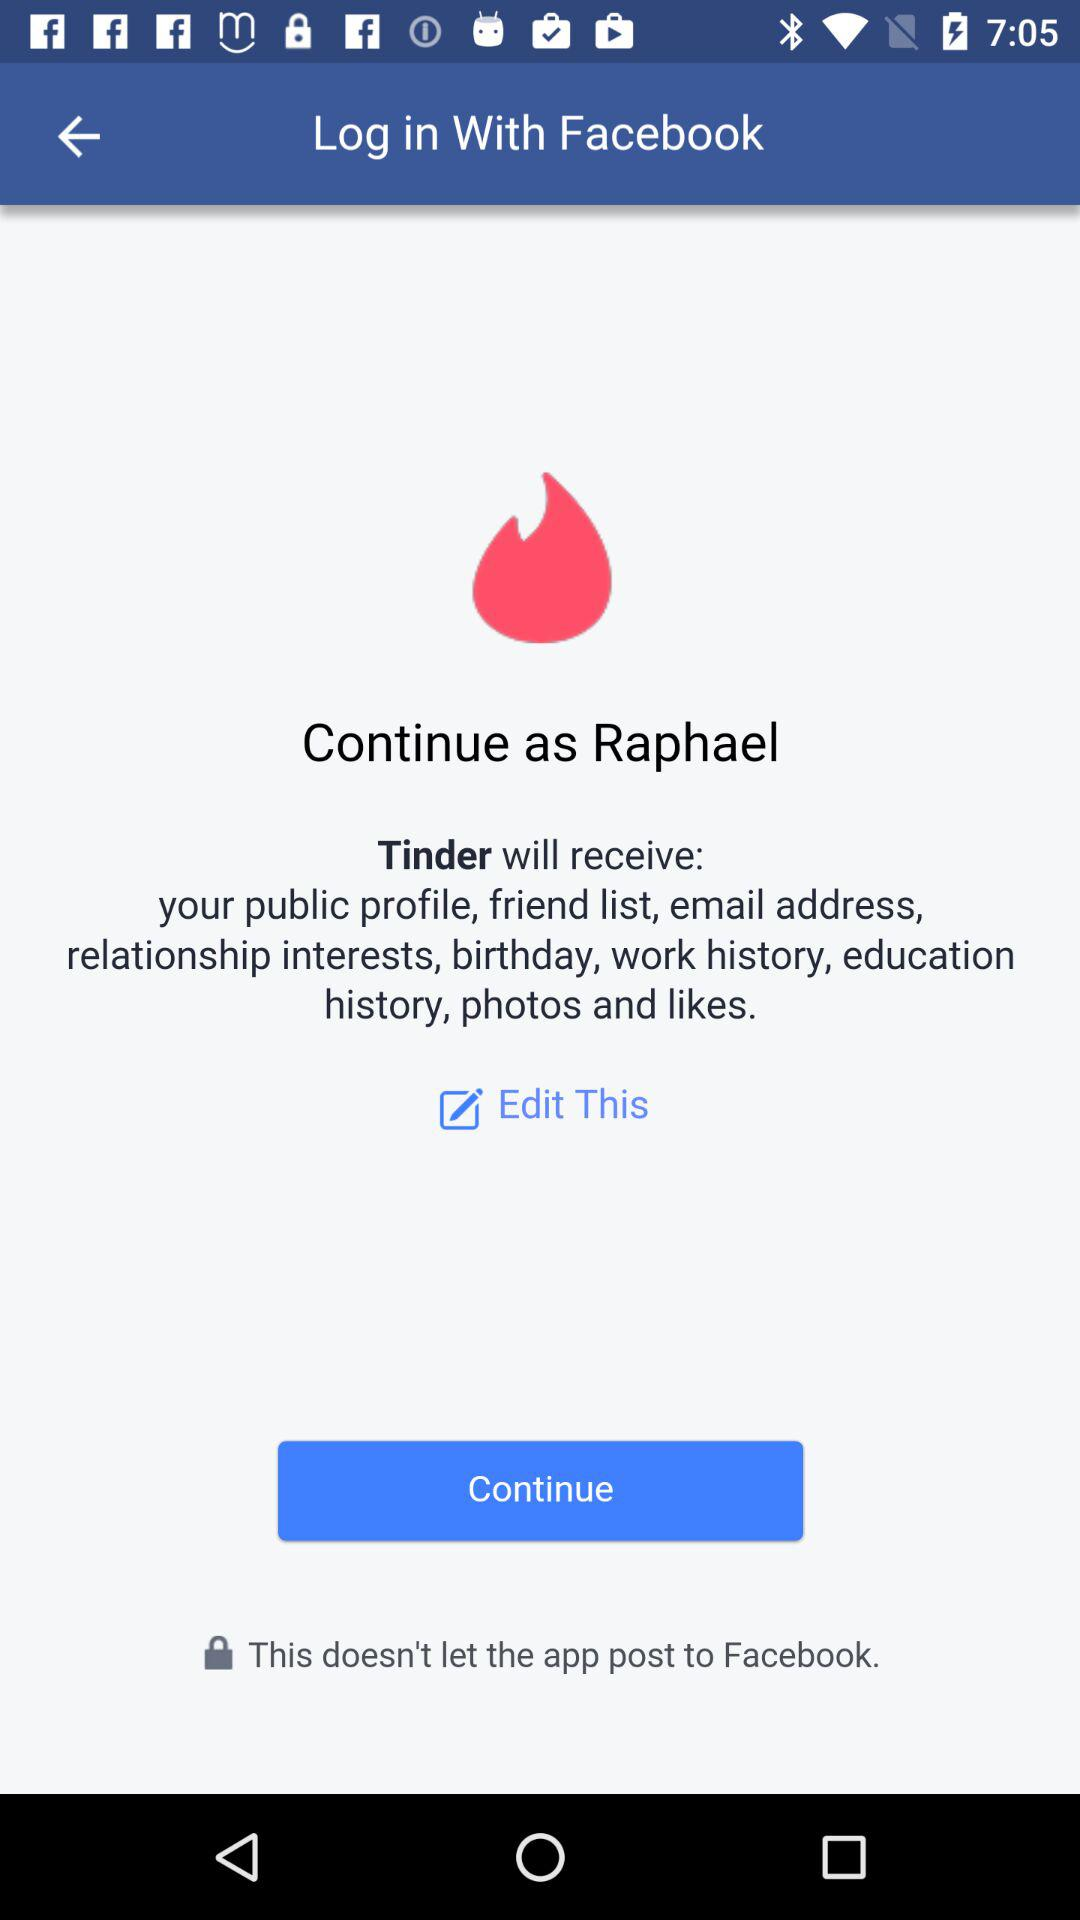Who will receive the public profile and email address? The application that will receive the public profile and email address is "Tinder". 